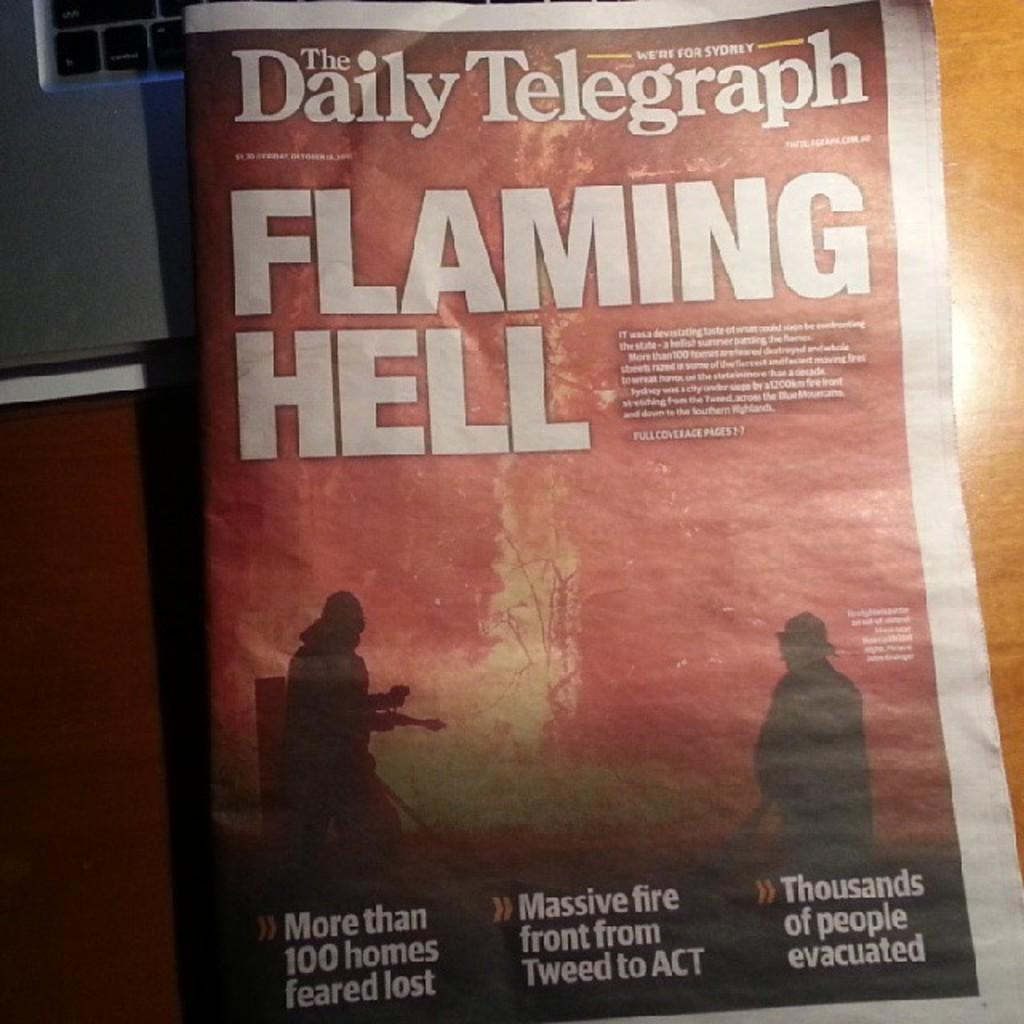<image>
Relay a brief, clear account of the picture shown. a copy of the daily telegraph with the headline "flaming hell" 